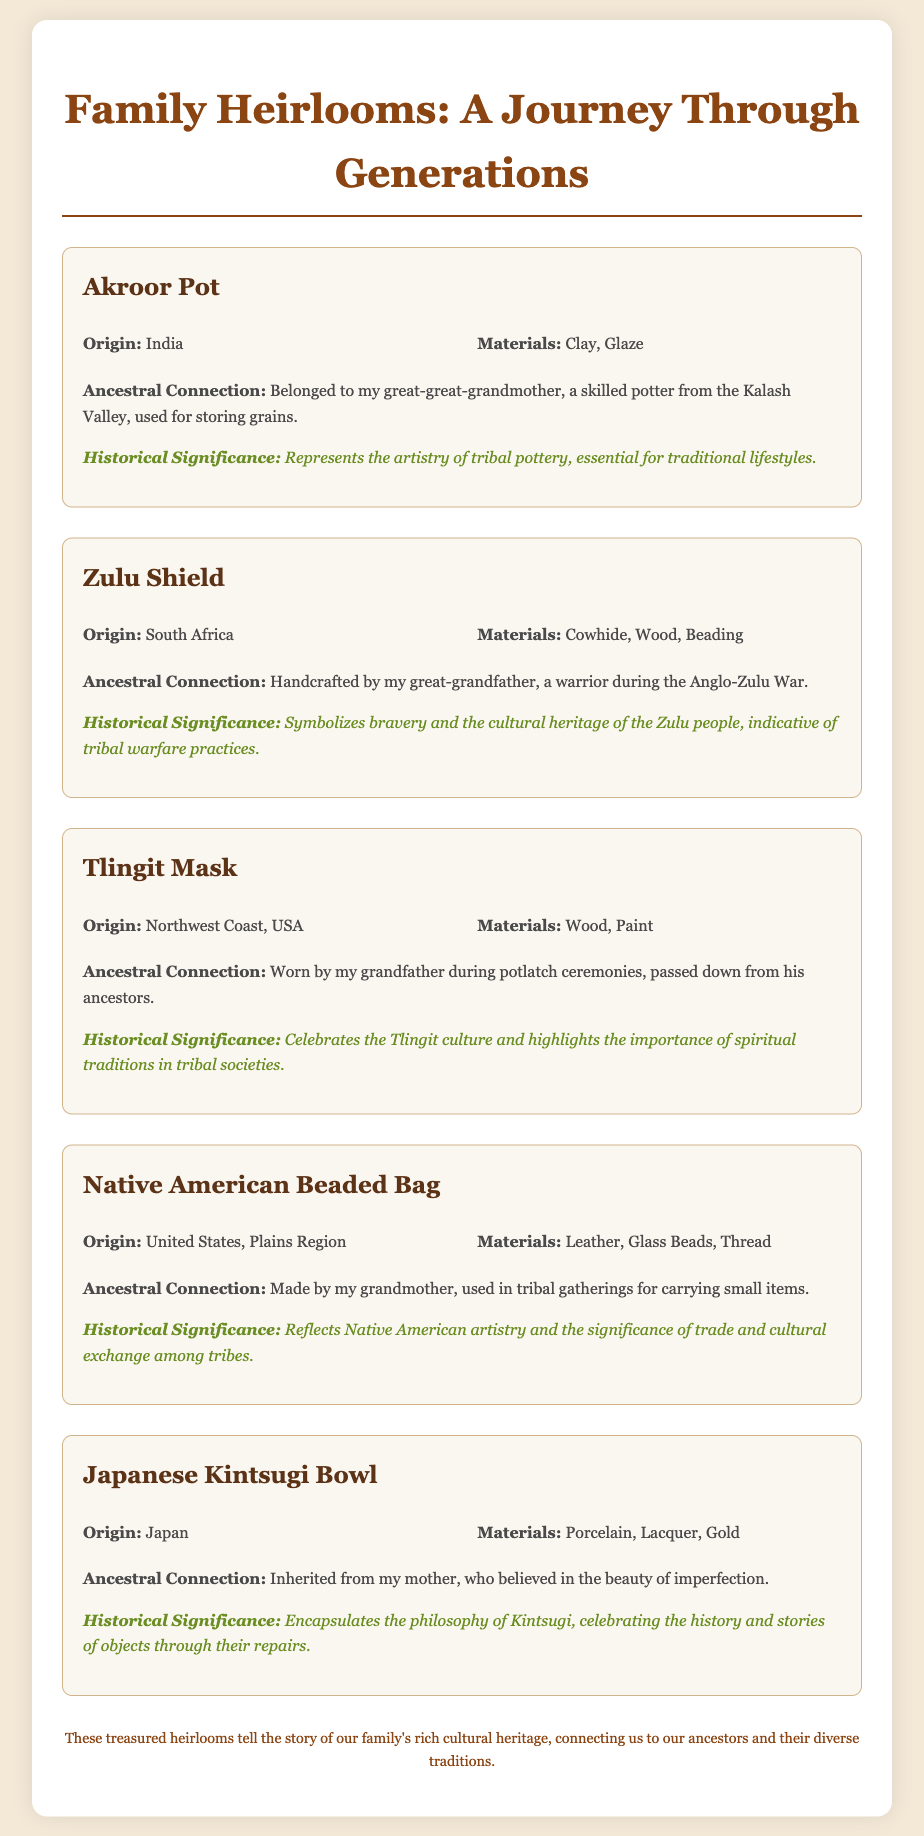What is the origin of the Akroor Pot? The origin is stated in the document as India.
Answer: India Who crafted the Zulu Shield? The document mentions it was handcrafted by the great-grandfather.
Answer: great-grandfather What material is the Tlingit Mask made of? The document lists wood and paint as the materials used for the mask.
Answer: Wood, Paint What does the Native American Beaded Bag reflect? The document describes it as reflecting Native American artistry and the significance of trade and cultural exchange.
Answer: Native American artistry and the significance of trade and cultural exchange What belief is associated with the Japanese Kintsugi Bowl? The document states that it is linked to the belief in the beauty of imperfection.
Answer: beauty of imperfection Which heirloom symbolizes bravery? The document specifies that the Zulu Shield symbolizes bravery.
Answer: Zulu Shield How many heirlooms are described in the document? Each heirloom listed in the document counts as one, and there are five mentioned.
Answer: five What ancestral connection is noted for the Akroor Pot? The document mentions it belonged to the great-great-grandmother, a skilled potter.
Answer: great-great-grandmother What cultural significance does the Zulu Shield hold? The document indicates it symbolizes the cultural heritage of the Zulu people.
Answer: cultural heritage of the Zulu people 